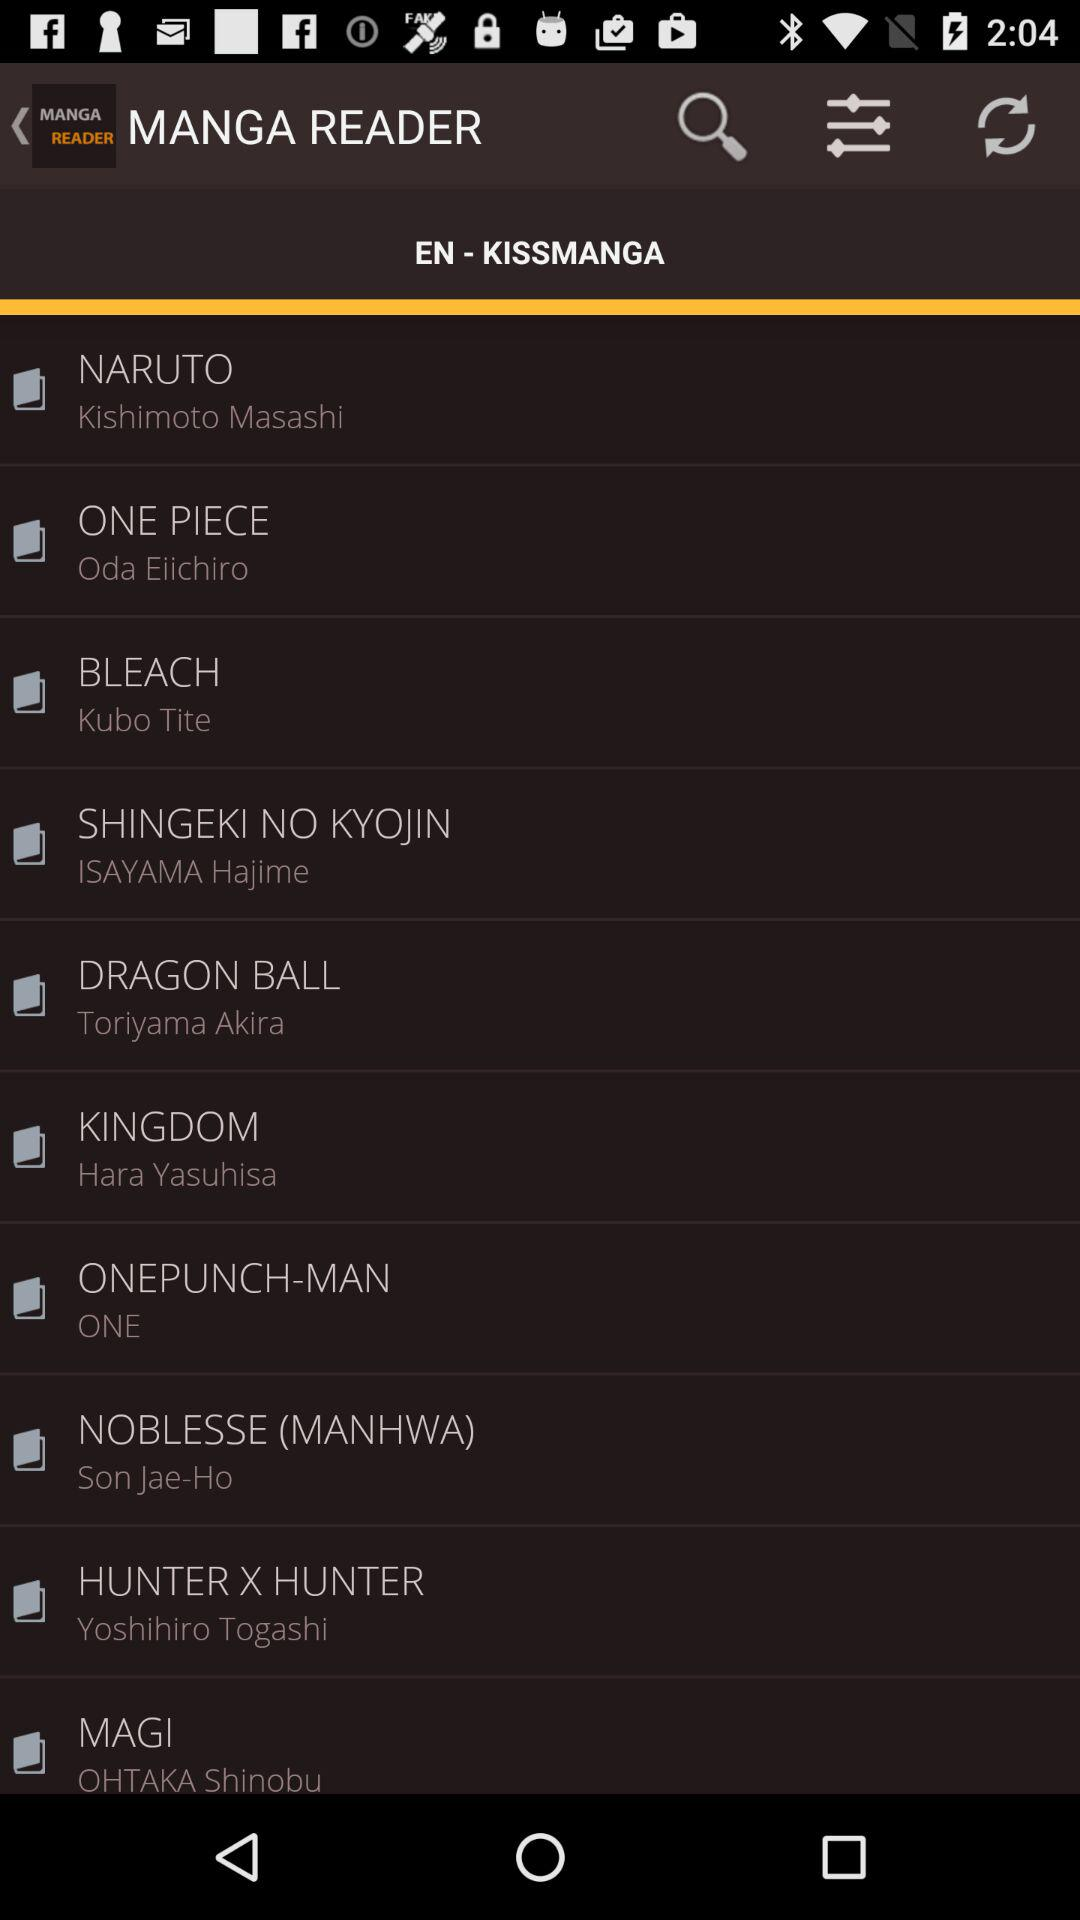Who wrote the series Naruto? The Naruto series is written by Kishimoto Masashi. 